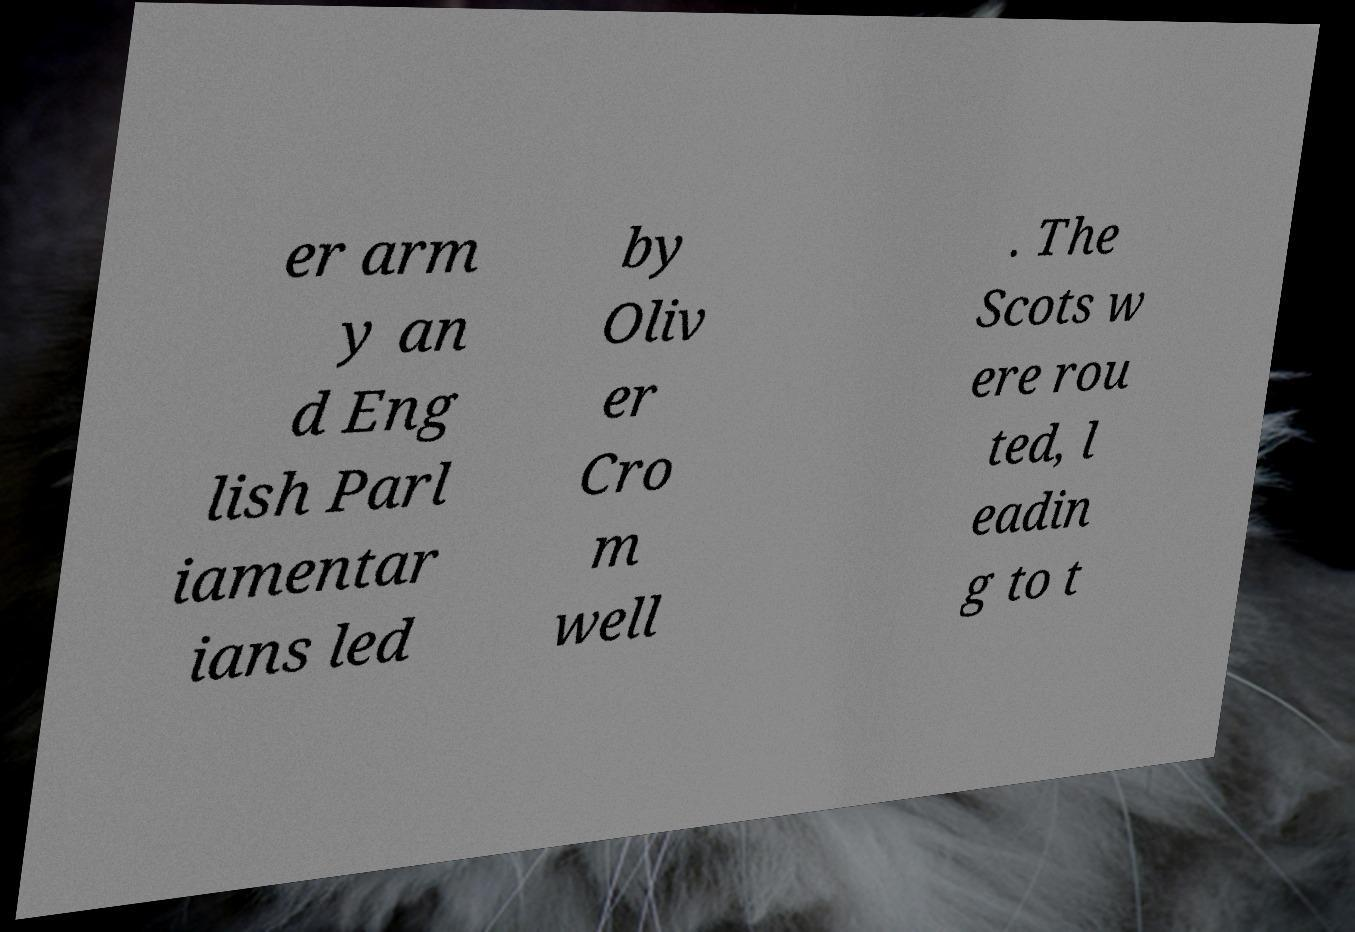What messages or text are displayed in this image? I need them in a readable, typed format. er arm y an d Eng lish Parl iamentar ians led by Oliv er Cro m well . The Scots w ere rou ted, l eadin g to t 